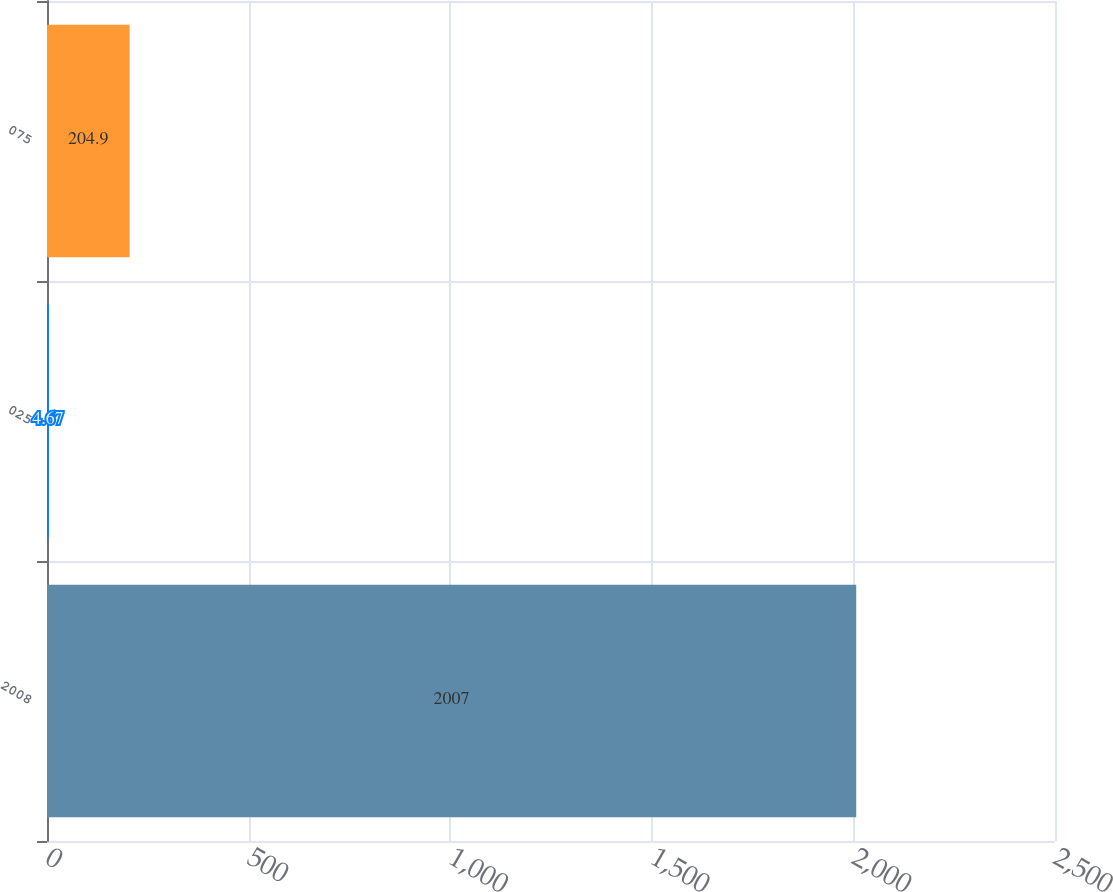<chart> <loc_0><loc_0><loc_500><loc_500><bar_chart><fcel>2008<fcel>025<fcel>075<nl><fcel>2007<fcel>4.67<fcel>204.9<nl></chart> 